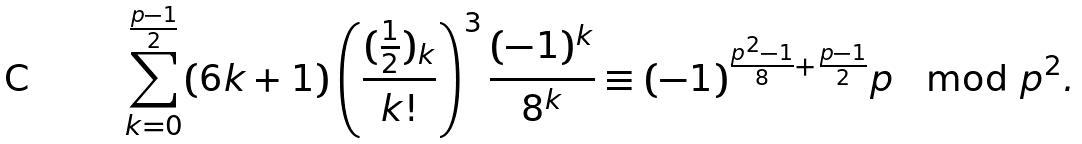<formula> <loc_0><loc_0><loc_500><loc_500>\sum _ { k = 0 } ^ { \frac { p - 1 } { 2 } } ( 6 k + 1 ) \left ( \frac { ( \frac { 1 } { 2 } ) _ { k } } { k ! } \right ) ^ { 3 } \frac { ( - 1 ) ^ { k } } { 8 ^ { k } } \equiv ( - 1 ) ^ { \frac { p ^ { 2 } - 1 } { 8 } + \frac { p - 1 } { 2 } } p \mod p ^ { 2 } .</formula> 